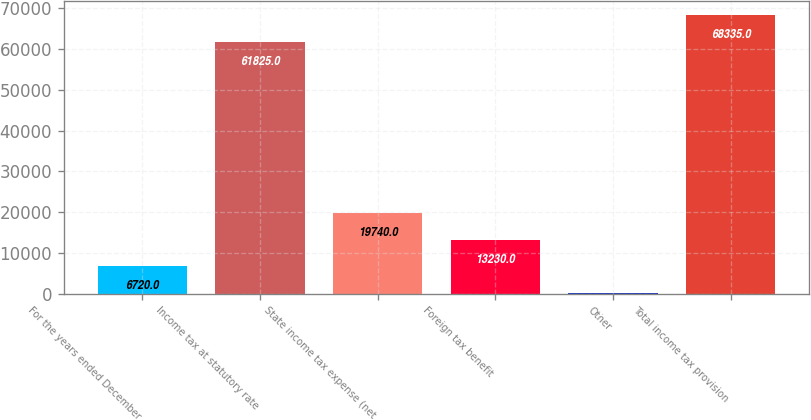Convert chart to OTSL. <chart><loc_0><loc_0><loc_500><loc_500><bar_chart><fcel>For the years ended December<fcel>Income tax at statutory rate<fcel>State income tax expense (net<fcel>Foreign tax benefit<fcel>Other<fcel>Total income tax provision<nl><fcel>6720<fcel>61825<fcel>19740<fcel>13230<fcel>210<fcel>68335<nl></chart> 